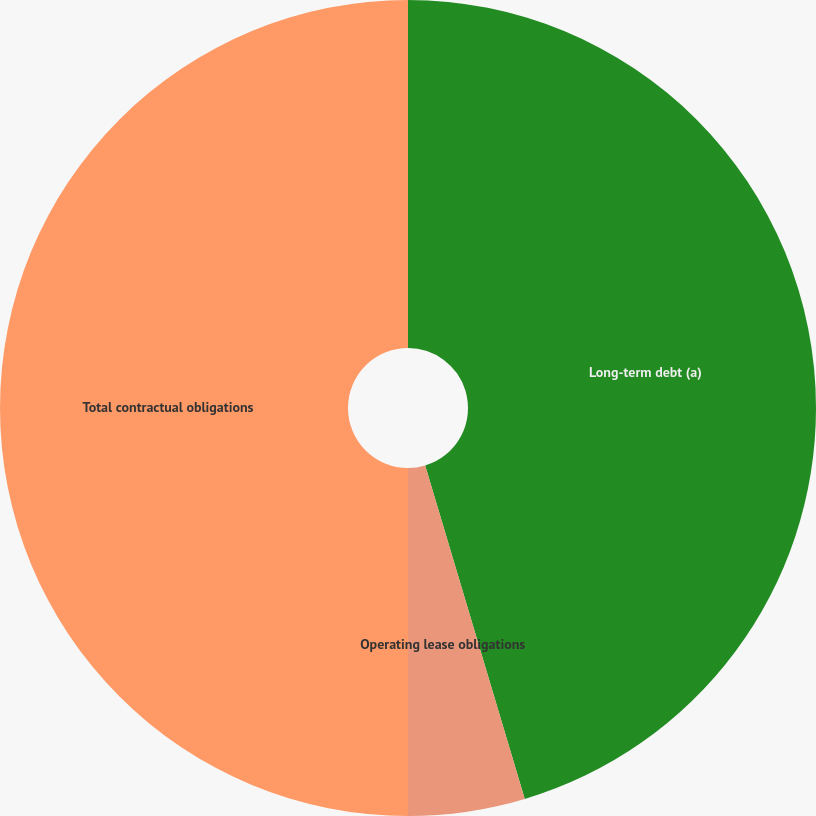Convert chart to OTSL. <chart><loc_0><loc_0><loc_500><loc_500><pie_chart><fcel>Long-term debt (a)<fcel>Operating lease obligations<fcel>Other long-term liabilities<fcel>Total contractual obligations<nl><fcel>45.38%<fcel>4.62%<fcel>0.0%<fcel>50.0%<nl></chart> 